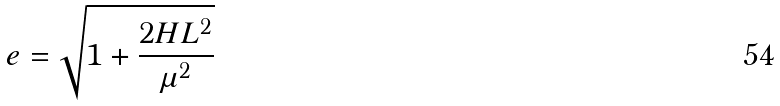<formula> <loc_0><loc_0><loc_500><loc_500>e = \sqrt { 1 + \frac { 2 H L ^ { 2 } } { \mu ^ { 2 } } }</formula> 